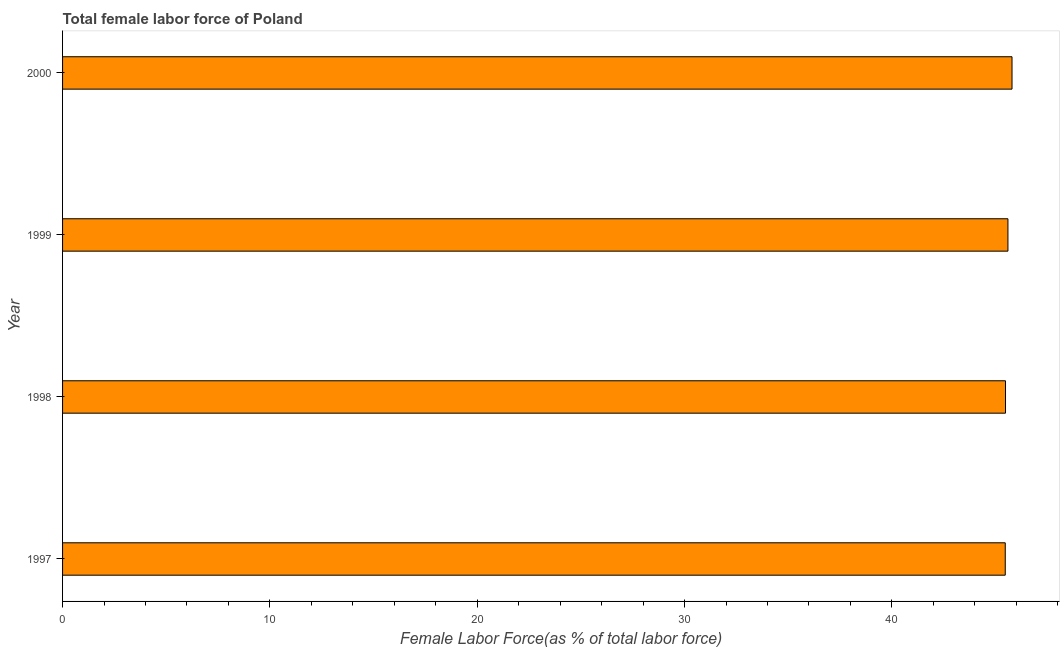Does the graph contain grids?
Offer a very short reply. No. What is the title of the graph?
Offer a very short reply. Total female labor force of Poland. What is the label or title of the X-axis?
Your answer should be compact. Female Labor Force(as % of total labor force). What is the total female labor force in 2000?
Offer a terse response. 45.8. Across all years, what is the maximum total female labor force?
Keep it short and to the point. 45.8. Across all years, what is the minimum total female labor force?
Keep it short and to the point. 45.47. What is the sum of the total female labor force?
Make the answer very short. 182.35. What is the difference between the total female labor force in 1997 and 2000?
Your response must be concise. -0.33. What is the average total female labor force per year?
Your answer should be compact. 45.59. What is the median total female labor force?
Provide a short and direct response. 45.54. In how many years, is the total female labor force greater than 32 %?
Offer a very short reply. 4. Do a majority of the years between 1998 and 1997 (inclusive) have total female labor force greater than 32 %?
Offer a very short reply. No. What is the ratio of the total female labor force in 1998 to that in 1999?
Keep it short and to the point. 1. Is the total female labor force in 1997 less than that in 1998?
Provide a short and direct response. Yes. Is the difference between the total female labor force in 1997 and 2000 greater than the difference between any two years?
Give a very brief answer. Yes. What is the difference between the highest and the second highest total female labor force?
Keep it short and to the point. 0.2. What is the difference between the highest and the lowest total female labor force?
Offer a very short reply. 0.33. In how many years, is the total female labor force greater than the average total female labor force taken over all years?
Offer a terse response. 2. How many bars are there?
Ensure brevity in your answer.  4. Are all the bars in the graph horizontal?
Provide a succinct answer. Yes. How many years are there in the graph?
Offer a terse response. 4. What is the difference between two consecutive major ticks on the X-axis?
Make the answer very short. 10. What is the Female Labor Force(as % of total labor force) in 1997?
Keep it short and to the point. 45.47. What is the Female Labor Force(as % of total labor force) in 1998?
Your answer should be very brief. 45.48. What is the Female Labor Force(as % of total labor force) in 1999?
Give a very brief answer. 45.6. What is the Female Labor Force(as % of total labor force) of 2000?
Keep it short and to the point. 45.8. What is the difference between the Female Labor Force(as % of total labor force) in 1997 and 1998?
Your response must be concise. -0.01. What is the difference between the Female Labor Force(as % of total labor force) in 1997 and 1999?
Provide a succinct answer. -0.13. What is the difference between the Female Labor Force(as % of total labor force) in 1997 and 2000?
Make the answer very short. -0.33. What is the difference between the Female Labor Force(as % of total labor force) in 1998 and 1999?
Make the answer very short. -0.12. What is the difference between the Female Labor Force(as % of total labor force) in 1998 and 2000?
Keep it short and to the point. -0.31. What is the difference between the Female Labor Force(as % of total labor force) in 1999 and 2000?
Make the answer very short. -0.2. What is the ratio of the Female Labor Force(as % of total labor force) in 1999 to that in 2000?
Provide a short and direct response. 1. 